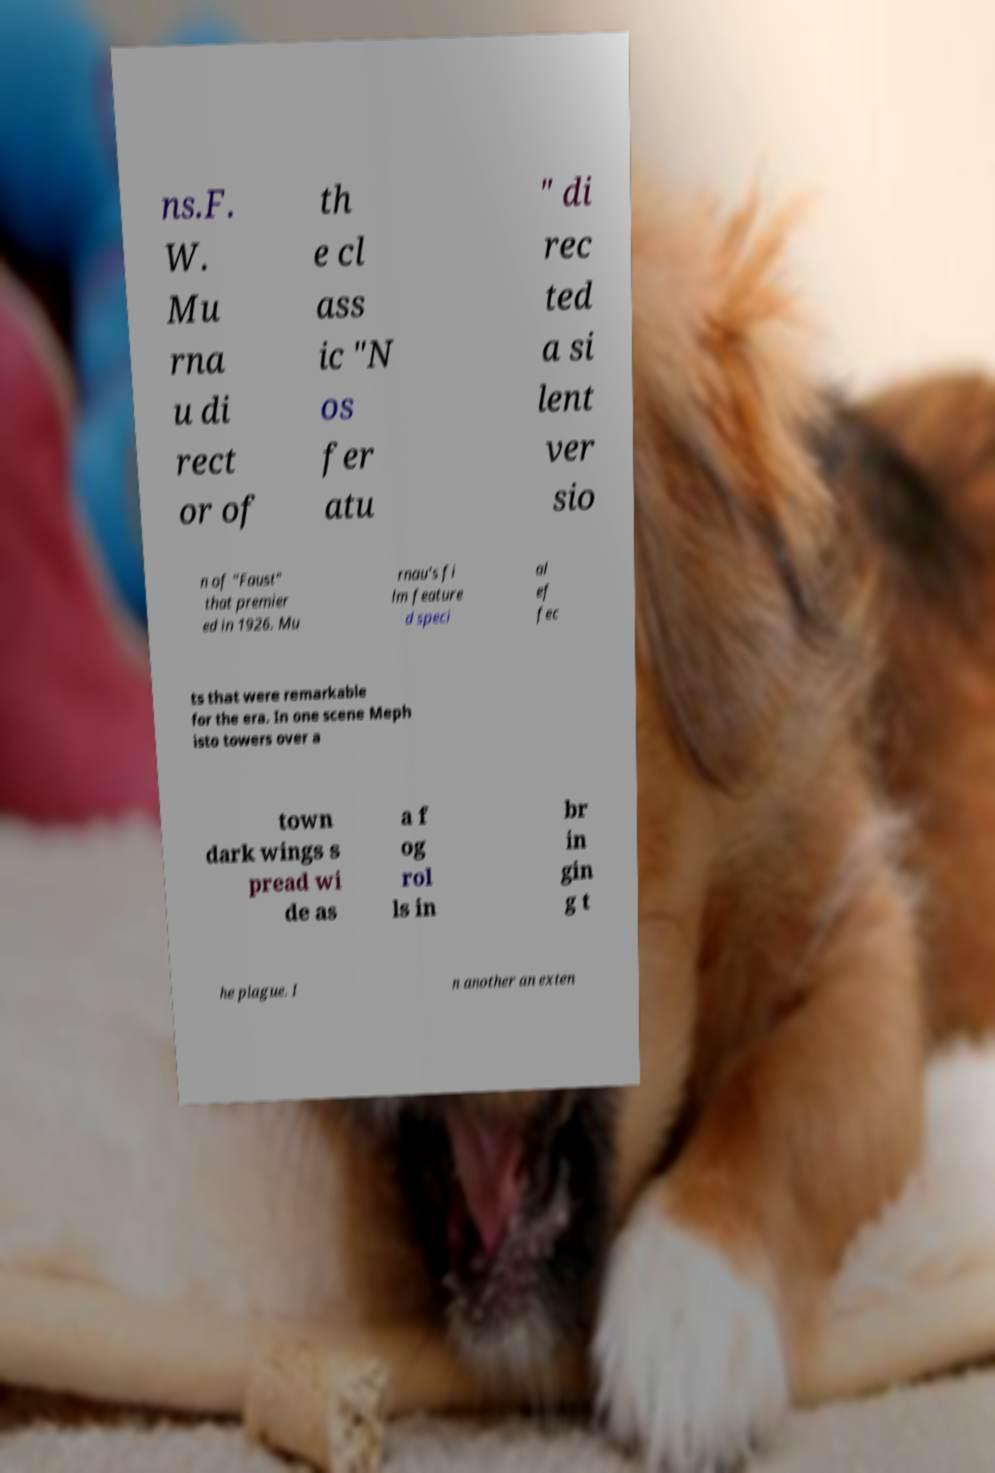Please identify and transcribe the text found in this image. ns.F. W. Mu rna u di rect or of th e cl ass ic "N os fer atu " di rec ted a si lent ver sio n of "Faust" that premier ed in 1926. Mu rnau's fi lm feature d speci al ef fec ts that were remarkable for the era. In one scene Meph isto towers over a town dark wings s pread wi de as a f og rol ls in br in gin g t he plague. I n another an exten 